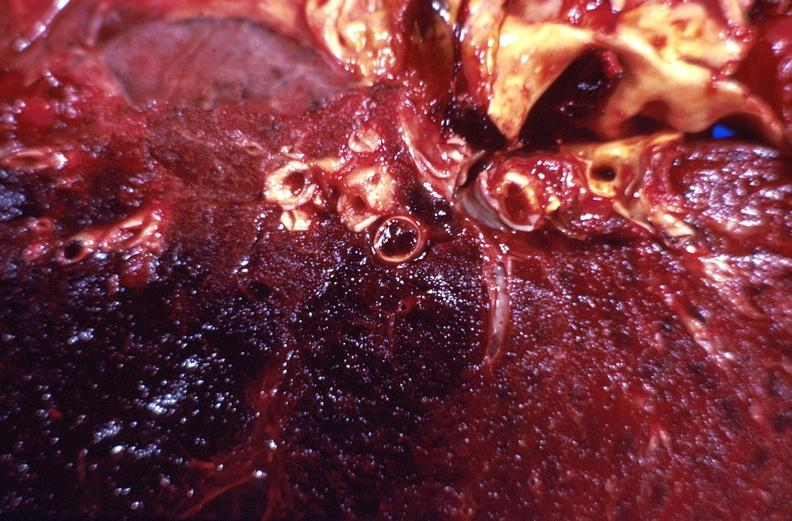what is present?
Answer the question using a single word or phrase. Respiratory 